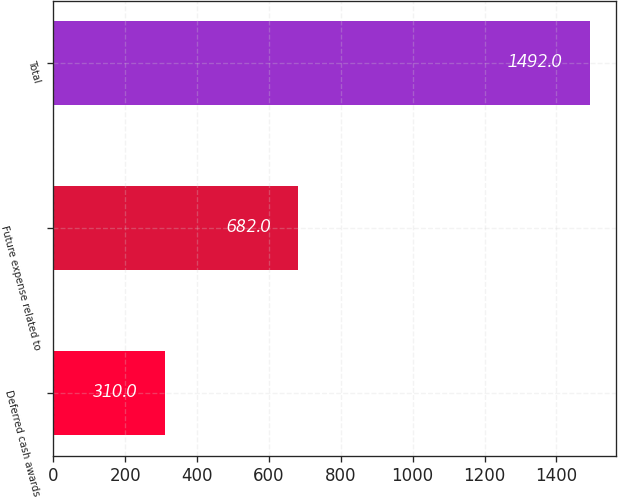<chart> <loc_0><loc_0><loc_500><loc_500><bar_chart><fcel>Deferred cash awards<fcel>Future expense related to<fcel>Total<nl><fcel>310<fcel>682<fcel>1492<nl></chart> 